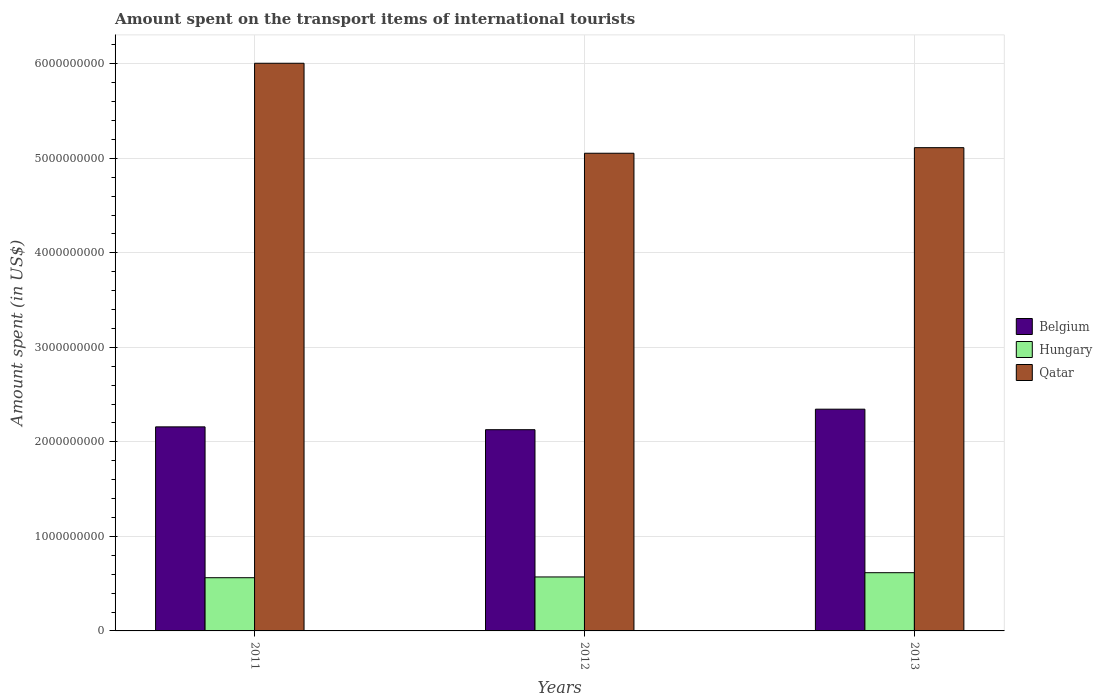How many different coloured bars are there?
Give a very brief answer. 3. How many groups of bars are there?
Your answer should be very brief. 3. Are the number of bars per tick equal to the number of legend labels?
Provide a succinct answer. Yes. Are the number of bars on each tick of the X-axis equal?
Your response must be concise. Yes. How many bars are there on the 3rd tick from the right?
Ensure brevity in your answer.  3. In how many cases, is the number of bars for a given year not equal to the number of legend labels?
Offer a very short reply. 0. What is the amount spent on the transport items of international tourists in Belgium in 2011?
Keep it short and to the point. 2.16e+09. Across all years, what is the maximum amount spent on the transport items of international tourists in Qatar?
Your answer should be compact. 6.01e+09. Across all years, what is the minimum amount spent on the transport items of international tourists in Hungary?
Provide a succinct answer. 5.63e+08. In which year was the amount spent on the transport items of international tourists in Hungary maximum?
Give a very brief answer. 2013. What is the total amount spent on the transport items of international tourists in Belgium in the graph?
Provide a succinct answer. 6.63e+09. What is the difference between the amount spent on the transport items of international tourists in Hungary in 2011 and that in 2013?
Provide a short and direct response. -5.30e+07. What is the difference between the amount spent on the transport items of international tourists in Hungary in 2012 and the amount spent on the transport items of international tourists in Belgium in 2013?
Your response must be concise. -1.78e+09. What is the average amount spent on the transport items of international tourists in Hungary per year?
Your response must be concise. 5.83e+08. In the year 2011, what is the difference between the amount spent on the transport items of international tourists in Qatar and amount spent on the transport items of international tourists in Belgium?
Provide a succinct answer. 3.85e+09. In how many years, is the amount spent on the transport items of international tourists in Belgium greater than 1600000000 US$?
Your response must be concise. 3. What is the ratio of the amount spent on the transport items of international tourists in Qatar in 2012 to that in 2013?
Make the answer very short. 0.99. What is the difference between the highest and the second highest amount spent on the transport items of international tourists in Belgium?
Offer a very short reply. 1.87e+08. What is the difference between the highest and the lowest amount spent on the transport items of international tourists in Belgium?
Keep it short and to the point. 2.17e+08. In how many years, is the amount spent on the transport items of international tourists in Hungary greater than the average amount spent on the transport items of international tourists in Hungary taken over all years?
Ensure brevity in your answer.  1. Is the sum of the amount spent on the transport items of international tourists in Qatar in 2012 and 2013 greater than the maximum amount spent on the transport items of international tourists in Hungary across all years?
Provide a short and direct response. Yes. What does the 3rd bar from the left in 2012 represents?
Provide a succinct answer. Qatar. What does the 1st bar from the right in 2013 represents?
Ensure brevity in your answer.  Qatar. Is it the case that in every year, the sum of the amount spent on the transport items of international tourists in Hungary and amount spent on the transport items of international tourists in Qatar is greater than the amount spent on the transport items of international tourists in Belgium?
Your response must be concise. Yes. How many years are there in the graph?
Give a very brief answer. 3. Does the graph contain any zero values?
Provide a succinct answer. No. Where does the legend appear in the graph?
Your answer should be compact. Center right. How many legend labels are there?
Offer a terse response. 3. What is the title of the graph?
Make the answer very short. Amount spent on the transport items of international tourists. What is the label or title of the X-axis?
Your answer should be very brief. Years. What is the label or title of the Y-axis?
Make the answer very short. Amount spent (in US$). What is the Amount spent (in US$) in Belgium in 2011?
Ensure brevity in your answer.  2.16e+09. What is the Amount spent (in US$) of Hungary in 2011?
Give a very brief answer. 5.63e+08. What is the Amount spent (in US$) of Qatar in 2011?
Your response must be concise. 6.01e+09. What is the Amount spent (in US$) of Belgium in 2012?
Offer a terse response. 2.13e+09. What is the Amount spent (in US$) of Hungary in 2012?
Give a very brief answer. 5.71e+08. What is the Amount spent (in US$) in Qatar in 2012?
Your answer should be very brief. 5.05e+09. What is the Amount spent (in US$) of Belgium in 2013?
Provide a short and direct response. 2.35e+09. What is the Amount spent (in US$) in Hungary in 2013?
Provide a short and direct response. 6.16e+08. What is the Amount spent (in US$) of Qatar in 2013?
Offer a terse response. 5.11e+09. Across all years, what is the maximum Amount spent (in US$) of Belgium?
Ensure brevity in your answer.  2.35e+09. Across all years, what is the maximum Amount spent (in US$) in Hungary?
Make the answer very short. 6.16e+08. Across all years, what is the maximum Amount spent (in US$) of Qatar?
Provide a succinct answer. 6.01e+09. Across all years, what is the minimum Amount spent (in US$) in Belgium?
Keep it short and to the point. 2.13e+09. Across all years, what is the minimum Amount spent (in US$) in Hungary?
Make the answer very short. 5.63e+08. Across all years, what is the minimum Amount spent (in US$) of Qatar?
Provide a short and direct response. 5.05e+09. What is the total Amount spent (in US$) of Belgium in the graph?
Your answer should be compact. 6.63e+09. What is the total Amount spent (in US$) in Hungary in the graph?
Give a very brief answer. 1.75e+09. What is the total Amount spent (in US$) in Qatar in the graph?
Your answer should be compact. 1.62e+1. What is the difference between the Amount spent (in US$) in Belgium in 2011 and that in 2012?
Keep it short and to the point. 3.00e+07. What is the difference between the Amount spent (in US$) in Hungary in 2011 and that in 2012?
Offer a very short reply. -8.00e+06. What is the difference between the Amount spent (in US$) of Qatar in 2011 and that in 2012?
Keep it short and to the point. 9.52e+08. What is the difference between the Amount spent (in US$) in Belgium in 2011 and that in 2013?
Provide a short and direct response. -1.87e+08. What is the difference between the Amount spent (in US$) in Hungary in 2011 and that in 2013?
Give a very brief answer. -5.30e+07. What is the difference between the Amount spent (in US$) of Qatar in 2011 and that in 2013?
Provide a succinct answer. 8.93e+08. What is the difference between the Amount spent (in US$) in Belgium in 2012 and that in 2013?
Offer a very short reply. -2.17e+08. What is the difference between the Amount spent (in US$) of Hungary in 2012 and that in 2013?
Keep it short and to the point. -4.50e+07. What is the difference between the Amount spent (in US$) in Qatar in 2012 and that in 2013?
Provide a short and direct response. -5.90e+07. What is the difference between the Amount spent (in US$) of Belgium in 2011 and the Amount spent (in US$) of Hungary in 2012?
Provide a succinct answer. 1.59e+09. What is the difference between the Amount spent (in US$) of Belgium in 2011 and the Amount spent (in US$) of Qatar in 2012?
Your answer should be compact. -2.90e+09. What is the difference between the Amount spent (in US$) of Hungary in 2011 and the Amount spent (in US$) of Qatar in 2012?
Ensure brevity in your answer.  -4.49e+09. What is the difference between the Amount spent (in US$) of Belgium in 2011 and the Amount spent (in US$) of Hungary in 2013?
Give a very brief answer. 1.54e+09. What is the difference between the Amount spent (in US$) of Belgium in 2011 and the Amount spent (in US$) of Qatar in 2013?
Your answer should be very brief. -2.95e+09. What is the difference between the Amount spent (in US$) of Hungary in 2011 and the Amount spent (in US$) of Qatar in 2013?
Offer a terse response. -4.55e+09. What is the difference between the Amount spent (in US$) in Belgium in 2012 and the Amount spent (in US$) in Hungary in 2013?
Keep it short and to the point. 1.51e+09. What is the difference between the Amount spent (in US$) in Belgium in 2012 and the Amount spent (in US$) in Qatar in 2013?
Offer a terse response. -2.98e+09. What is the difference between the Amount spent (in US$) in Hungary in 2012 and the Amount spent (in US$) in Qatar in 2013?
Offer a very short reply. -4.54e+09. What is the average Amount spent (in US$) in Belgium per year?
Keep it short and to the point. 2.21e+09. What is the average Amount spent (in US$) of Hungary per year?
Offer a terse response. 5.83e+08. What is the average Amount spent (in US$) of Qatar per year?
Offer a very short reply. 5.39e+09. In the year 2011, what is the difference between the Amount spent (in US$) of Belgium and Amount spent (in US$) of Hungary?
Your answer should be very brief. 1.60e+09. In the year 2011, what is the difference between the Amount spent (in US$) in Belgium and Amount spent (in US$) in Qatar?
Offer a very short reply. -3.85e+09. In the year 2011, what is the difference between the Amount spent (in US$) of Hungary and Amount spent (in US$) of Qatar?
Give a very brief answer. -5.44e+09. In the year 2012, what is the difference between the Amount spent (in US$) of Belgium and Amount spent (in US$) of Hungary?
Your response must be concise. 1.56e+09. In the year 2012, what is the difference between the Amount spent (in US$) of Belgium and Amount spent (in US$) of Qatar?
Provide a succinct answer. -2.92e+09. In the year 2012, what is the difference between the Amount spent (in US$) in Hungary and Amount spent (in US$) in Qatar?
Offer a terse response. -4.48e+09. In the year 2013, what is the difference between the Amount spent (in US$) of Belgium and Amount spent (in US$) of Hungary?
Ensure brevity in your answer.  1.73e+09. In the year 2013, what is the difference between the Amount spent (in US$) of Belgium and Amount spent (in US$) of Qatar?
Ensure brevity in your answer.  -2.77e+09. In the year 2013, what is the difference between the Amount spent (in US$) of Hungary and Amount spent (in US$) of Qatar?
Your response must be concise. -4.50e+09. What is the ratio of the Amount spent (in US$) in Belgium in 2011 to that in 2012?
Provide a succinct answer. 1.01. What is the ratio of the Amount spent (in US$) in Qatar in 2011 to that in 2012?
Make the answer very short. 1.19. What is the ratio of the Amount spent (in US$) of Belgium in 2011 to that in 2013?
Ensure brevity in your answer.  0.92. What is the ratio of the Amount spent (in US$) in Hungary in 2011 to that in 2013?
Provide a short and direct response. 0.91. What is the ratio of the Amount spent (in US$) in Qatar in 2011 to that in 2013?
Keep it short and to the point. 1.17. What is the ratio of the Amount spent (in US$) of Belgium in 2012 to that in 2013?
Make the answer very short. 0.91. What is the ratio of the Amount spent (in US$) of Hungary in 2012 to that in 2013?
Offer a terse response. 0.93. What is the difference between the highest and the second highest Amount spent (in US$) of Belgium?
Offer a very short reply. 1.87e+08. What is the difference between the highest and the second highest Amount spent (in US$) of Hungary?
Ensure brevity in your answer.  4.50e+07. What is the difference between the highest and the second highest Amount spent (in US$) of Qatar?
Keep it short and to the point. 8.93e+08. What is the difference between the highest and the lowest Amount spent (in US$) in Belgium?
Offer a very short reply. 2.17e+08. What is the difference between the highest and the lowest Amount spent (in US$) of Hungary?
Provide a short and direct response. 5.30e+07. What is the difference between the highest and the lowest Amount spent (in US$) of Qatar?
Offer a very short reply. 9.52e+08. 